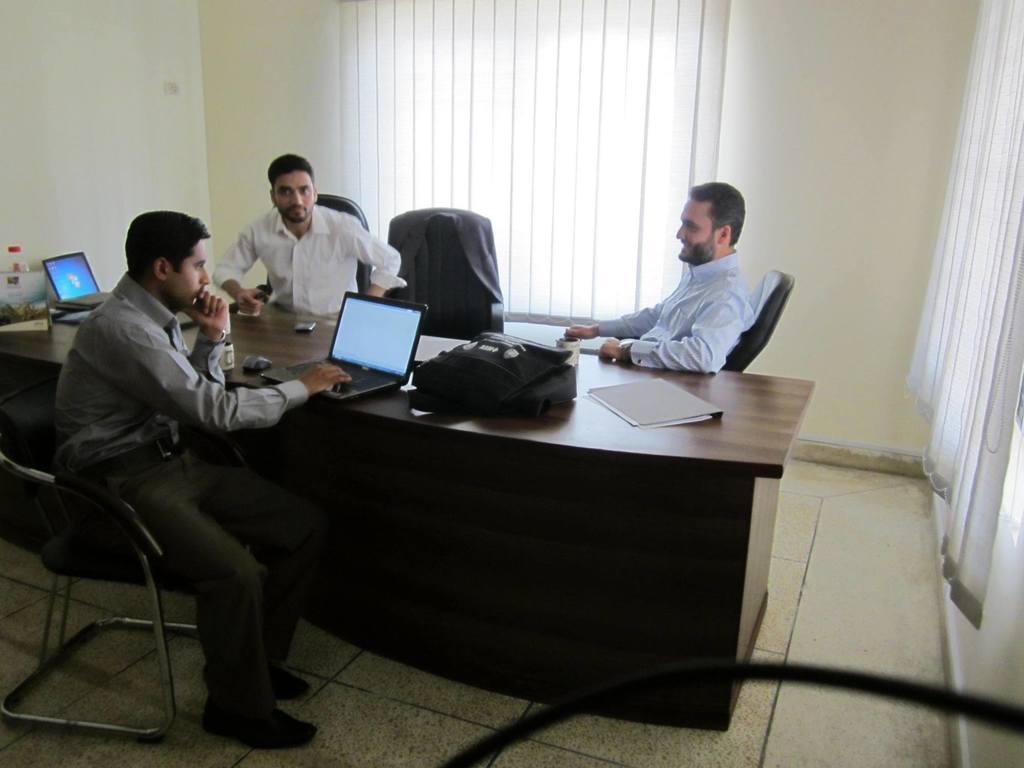Please provide a concise description of this image. In this image there is a table which is in black color on the table there is a book, there is a bag,there is a laptop and some people are sitting on the chairs and in the background there is a wall and some curtains off white color. 